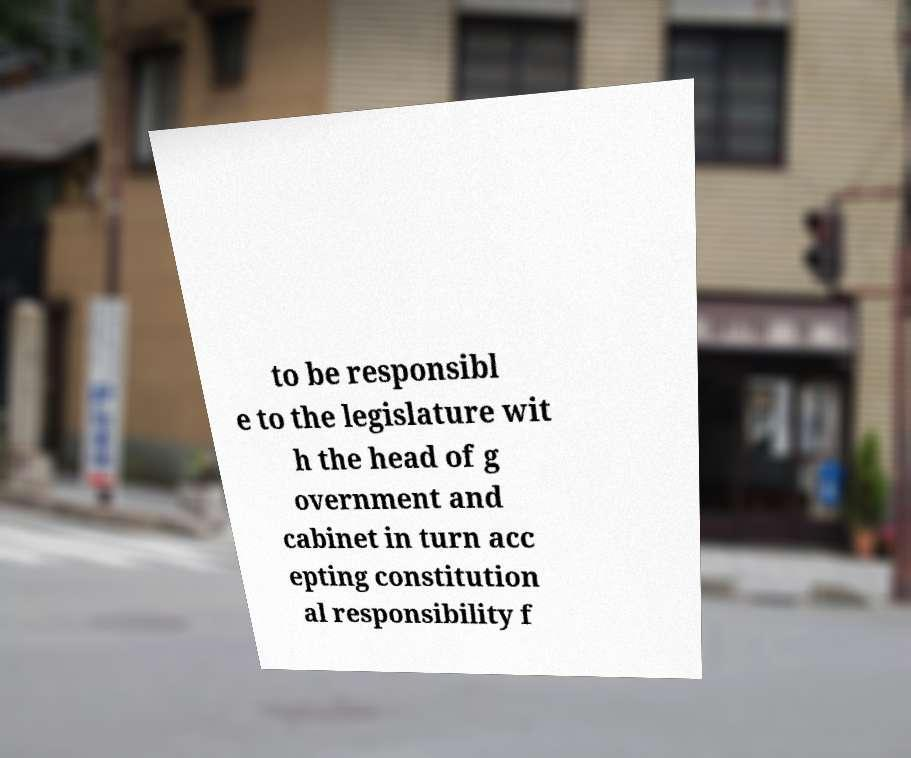What messages or text are displayed in this image? I need them in a readable, typed format. to be responsibl e to the legislature wit h the head of g overnment and cabinet in turn acc epting constitution al responsibility f 